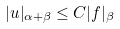Convert formula to latex. <formula><loc_0><loc_0><loc_500><loc_500>| u | _ { \alpha + \beta } \leq C | f | _ { \beta }</formula> 